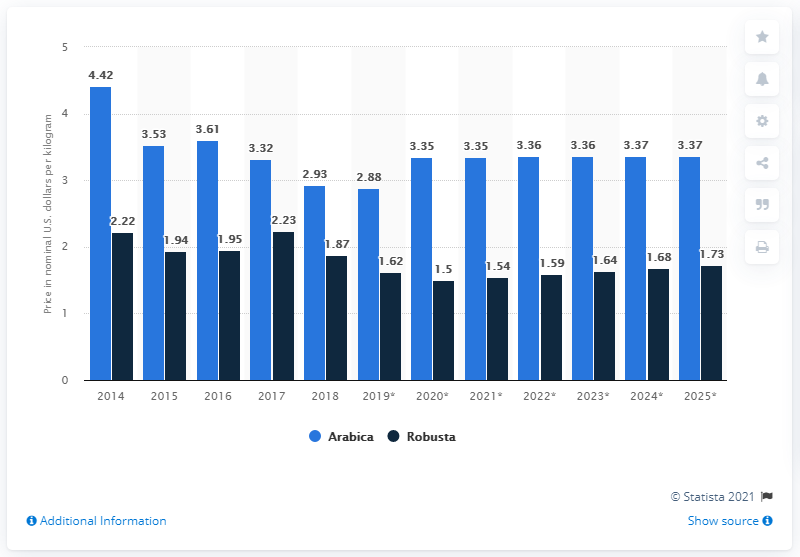Outline some significant characteristics in this image. In 2014, the difference between Arabica and Robusta coffee was at its highest level. In 2019, the price of Arabica coffee was the least. Robusta coffee beans have the ability to grow at a wider range of altitudes and temperatures, making them more adaptable than other types of coffee beans. In 2018, the price per kilogram of Arabica coffee was 2.93. 